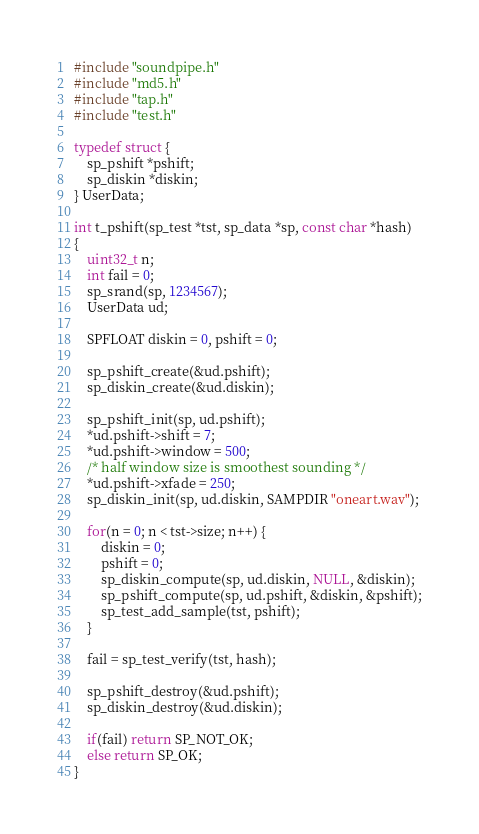Convert code to text. <code><loc_0><loc_0><loc_500><loc_500><_C_>#include "soundpipe.h"
#include "md5.h"
#include "tap.h"
#include "test.h"

typedef struct {
    sp_pshift *pshift;
    sp_diskin *diskin;
} UserData;

int t_pshift(sp_test *tst, sp_data *sp, const char *hash)
{
    uint32_t n;
    int fail = 0;
    sp_srand(sp, 1234567);
    UserData ud;

    SPFLOAT diskin = 0, pshift = 0;

    sp_pshift_create(&ud.pshift);
    sp_diskin_create(&ud.diskin);

    sp_pshift_init(sp, ud.pshift);
    *ud.pshift->shift = 7;
    *ud.pshift->window = 500;
    /* half window size is smoothest sounding */
    *ud.pshift->xfade = 250;
    sp_diskin_init(sp, ud.diskin, SAMPDIR "oneart.wav");

    for(n = 0; n < tst->size; n++) {
        diskin = 0;
        pshift = 0;
        sp_diskin_compute(sp, ud.diskin, NULL, &diskin);
        sp_pshift_compute(sp, ud.pshift, &diskin, &pshift);
        sp_test_add_sample(tst, pshift);
    }

    fail = sp_test_verify(tst, hash);

    sp_pshift_destroy(&ud.pshift);
    sp_diskin_destroy(&ud.diskin);

    if(fail) return SP_NOT_OK;
    else return SP_OK;
}
</code> 